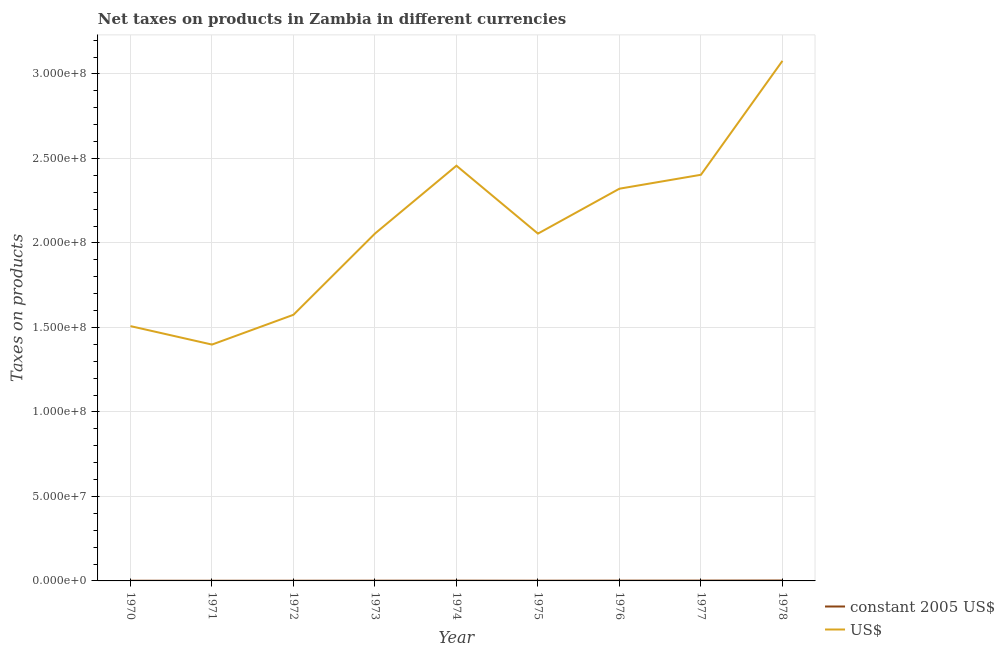Is the number of lines equal to the number of legend labels?
Ensure brevity in your answer.  Yes. What is the net taxes in constant 2005 us$ in 1977?
Your answer should be compact. 1.90e+05. Across all years, what is the maximum net taxes in constant 2005 us$?
Provide a succinct answer. 2.46e+05. Across all years, what is the minimum net taxes in us$?
Offer a terse response. 1.40e+08. In which year was the net taxes in constant 2005 us$ maximum?
Your response must be concise. 1978. What is the total net taxes in us$ in the graph?
Your answer should be compact. 1.89e+09. What is the difference between the net taxes in constant 2005 us$ in 1973 and that in 1978?
Provide a short and direct response. -1.12e+05. What is the difference between the net taxes in constant 2005 us$ in 1977 and the net taxes in us$ in 1973?
Give a very brief answer. -2.05e+08. What is the average net taxes in us$ per year?
Provide a succinct answer. 2.09e+08. In the year 1977, what is the difference between the net taxes in us$ and net taxes in constant 2005 us$?
Offer a terse response. 2.40e+08. In how many years, is the net taxes in us$ greater than 100000000 units?
Keep it short and to the point. 9. What is the ratio of the net taxes in constant 2005 us$ in 1973 to that in 1974?
Ensure brevity in your answer.  0.85. Is the difference between the net taxes in constant 2005 us$ in 1972 and 1976 greater than the difference between the net taxes in us$ in 1972 and 1976?
Your response must be concise. Yes. What is the difference between the highest and the second highest net taxes in constant 2005 us$?
Keep it short and to the point. 5.66e+04. What is the difference between the highest and the lowest net taxes in us$?
Keep it short and to the point. 1.68e+08. Does the net taxes in us$ monotonically increase over the years?
Your response must be concise. No. Is the net taxes in us$ strictly greater than the net taxes in constant 2005 us$ over the years?
Give a very brief answer. Yes. Is the net taxes in us$ strictly less than the net taxes in constant 2005 us$ over the years?
Provide a short and direct response. No. How many lines are there?
Ensure brevity in your answer.  2. How many years are there in the graph?
Provide a succinct answer. 9. Does the graph contain any zero values?
Keep it short and to the point. No. Does the graph contain grids?
Your answer should be compact. Yes. How many legend labels are there?
Your response must be concise. 2. What is the title of the graph?
Make the answer very short. Net taxes on products in Zambia in different currencies. What is the label or title of the Y-axis?
Your response must be concise. Taxes on products. What is the Taxes on products of constant 2005 US$ in 1970?
Your answer should be very brief. 1.08e+05. What is the Taxes on products in US$ in 1970?
Offer a very short reply. 1.51e+08. What is the Taxes on products in constant 2005 US$ in 1971?
Ensure brevity in your answer.  9.99e+04. What is the Taxes on products in US$ in 1971?
Keep it short and to the point. 1.40e+08. What is the Taxes on products in constant 2005 US$ in 1972?
Provide a succinct answer. 1.12e+05. What is the Taxes on products in US$ in 1972?
Provide a succinct answer. 1.57e+08. What is the Taxes on products in constant 2005 US$ in 1973?
Your answer should be compact. 1.34e+05. What is the Taxes on products in US$ in 1973?
Offer a very short reply. 2.06e+08. What is the Taxes on products of constant 2005 US$ in 1974?
Make the answer very short. 1.58e+05. What is the Taxes on products in US$ in 1974?
Your response must be concise. 2.46e+08. What is the Taxes on products in constant 2005 US$ in 1975?
Your answer should be compact. 1.32e+05. What is the Taxes on products in US$ in 1975?
Give a very brief answer. 2.06e+08. What is the Taxes on products in constant 2005 US$ in 1976?
Make the answer very short. 1.63e+05. What is the Taxes on products in US$ in 1976?
Provide a succinct answer. 2.32e+08. What is the Taxes on products in constant 2005 US$ in 1977?
Your answer should be compact. 1.90e+05. What is the Taxes on products of US$ in 1977?
Keep it short and to the point. 2.40e+08. What is the Taxes on products in constant 2005 US$ in 1978?
Provide a short and direct response. 2.46e+05. What is the Taxes on products of US$ in 1978?
Provide a short and direct response. 3.08e+08. Across all years, what is the maximum Taxes on products of constant 2005 US$?
Offer a very short reply. 2.46e+05. Across all years, what is the maximum Taxes on products of US$?
Provide a short and direct response. 3.08e+08. Across all years, what is the minimum Taxes on products of constant 2005 US$?
Your answer should be very brief. 9.99e+04. Across all years, what is the minimum Taxes on products in US$?
Your response must be concise. 1.40e+08. What is the total Taxes on products of constant 2005 US$ in the graph?
Offer a very short reply. 1.34e+06. What is the total Taxes on products in US$ in the graph?
Your answer should be very brief. 1.89e+09. What is the difference between the Taxes on products in constant 2005 US$ in 1970 and that in 1971?
Make the answer very short. 7800. What is the difference between the Taxes on products of US$ in 1970 and that in 1971?
Keep it short and to the point. 1.09e+07. What is the difference between the Taxes on products in constant 2005 US$ in 1970 and that in 1972?
Keep it short and to the point. -4800. What is the difference between the Taxes on products of US$ in 1970 and that in 1972?
Ensure brevity in your answer.  -6.71e+06. What is the difference between the Taxes on products of constant 2005 US$ in 1970 and that in 1973?
Give a very brief answer. -2.64e+04. What is the difference between the Taxes on products in US$ in 1970 and that in 1973?
Keep it short and to the point. -5.48e+07. What is the difference between the Taxes on products in constant 2005 US$ in 1970 and that in 1974?
Offer a terse response. -5.04e+04. What is the difference between the Taxes on products in US$ in 1970 and that in 1974?
Ensure brevity in your answer.  -9.49e+07. What is the difference between the Taxes on products in constant 2005 US$ in 1970 and that in 1975?
Keep it short and to the point. -2.45e+04. What is the difference between the Taxes on products of US$ in 1970 and that in 1975?
Keep it short and to the point. -5.47e+07. What is the difference between the Taxes on products of constant 2005 US$ in 1970 and that in 1976?
Your answer should be compact. -5.50e+04. What is the difference between the Taxes on products in US$ in 1970 and that in 1976?
Your answer should be very brief. -8.13e+07. What is the difference between the Taxes on products of constant 2005 US$ in 1970 and that in 1977?
Provide a short and direct response. -8.21e+04. What is the difference between the Taxes on products in US$ in 1970 and that in 1977?
Your answer should be compact. -8.96e+07. What is the difference between the Taxes on products of constant 2005 US$ in 1970 and that in 1978?
Ensure brevity in your answer.  -1.39e+05. What is the difference between the Taxes on products in US$ in 1970 and that in 1978?
Offer a very short reply. -1.57e+08. What is the difference between the Taxes on products of constant 2005 US$ in 1971 and that in 1972?
Your answer should be compact. -1.26e+04. What is the difference between the Taxes on products of US$ in 1971 and that in 1972?
Provide a short and direct response. -1.76e+07. What is the difference between the Taxes on products of constant 2005 US$ in 1971 and that in 1973?
Offer a very short reply. -3.42e+04. What is the difference between the Taxes on products in US$ in 1971 and that in 1973?
Provide a succinct answer. -6.57e+07. What is the difference between the Taxes on products in constant 2005 US$ in 1971 and that in 1974?
Make the answer very short. -5.82e+04. What is the difference between the Taxes on products of US$ in 1971 and that in 1974?
Keep it short and to the point. -1.06e+08. What is the difference between the Taxes on products in constant 2005 US$ in 1971 and that in 1975?
Give a very brief answer. -3.23e+04. What is the difference between the Taxes on products of US$ in 1971 and that in 1975?
Offer a very short reply. -6.57e+07. What is the difference between the Taxes on products of constant 2005 US$ in 1971 and that in 1976?
Offer a very short reply. -6.28e+04. What is the difference between the Taxes on products of US$ in 1971 and that in 1976?
Provide a succinct answer. -9.22e+07. What is the difference between the Taxes on products of constant 2005 US$ in 1971 and that in 1977?
Provide a short and direct response. -8.99e+04. What is the difference between the Taxes on products of US$ in 1971 and that in 1977?
Your response must be concise. -1.00e+08. What is the difference between the Taxes on products of constant 2005 US$ in 1971 and that in 1978?
Offer a very short reply. -1.46e+05. What is the difference between the Taxes on products in US$ in 1971 and that in 1978?
Provide a succinct answer. -1.68e+08. What is the difference between the Taxes on products of constant 2005 US$ in 1972 and that in 1973?
Your answer should be very brief. -2.16e+04. What is the difference between the Taxes on products in US$ in 1972 and that in 1973?
Offer a terse response. -4.81e+07. What is the difference between the Taxes on products of constant 2005 US$ in 1972 and that in 1974?
Offer a very short reply. -4.56e+04. What is the difference between the Taxes on products of US$ in 1972 and that in 1974?
Ensure brevity in your answer.  -8.82e+07. What is the difference between the Taxes on products in constant 2005 US$ in 1972 and that in 1975?
Your answer should be compact. -1.97e+04. What is the difference between the Taxes on products in US$ in 1972 and that in 1975?
Make the answer very short. -4.80e+07. What is the difference between the Taxes on products in constant 2005 US$ in 1972 and that in 1976?
Make the answer very short. -5.02e+04. What is the difference between the Taxes on products of US$ in 1972 and that in 1976?
Offer a terse response. -7.46e+07. What is the difference between the Taxes on products in constant 2005 US$ in 1972 and that in 1977?
Keep it short and to the point. -7.73e+04. What is the difference between the Taxes on products in US$ in 1972 and that in 1977?
Provide a short and direct response. -8.28e+07. What is the difference between the Taxes on products in constant 2005 US$ in 1972 and that in 1978?
Offer a terse response. -1.34e+05. What is the difference between the Taxes on products in US$ in 1972 and that in 1978?
Give a very brief answer. -1.50e+08. What is the difference between the Taxes on products of constant 2005 US$ in 1973 and that in 1974?
Your answer should be very brief. -2.40e+04. What is the difference between the Taxes on products of US$ in 1973 and that in 1974?
Ensure brevity in your answer.  -4.02e+07. What is the difference between the Taxes on products of constant 2005 US$ in 1973 and that in 1975?
Provide a short and direct response. 1900. What is the difference between the Taxes on products of US$ in 1973 and that in 1975?
Give a very brief answer. 2.46e+04. What is the difference between the Taxes on products of constant 2005 US$ in 1973 and that in 1976?
Provide a short and direct response. -2.86e+04. What is the difference between the Taxes on products in US$ in 1973 and that in 1976?
Make the answer very short. -2.66e+07. What is the difference between the Taxes on products in constant 2005 US$ in 1973 and that in 1977?
Make the answer very short. -5.57e+04. What is the difference between the Taxes on products in US$ in 1973 and that in 1977?
Keep it short and to the point. -3.48e+07. What is the difference between the Taxes on products of constant 2005 US$ in 1973 and that in 1978?
Provide a short and direct response. -1.12e+05. What is the difference between the Taxes on products in US$ in 1973 and that in 1978?
Ensure brevity in your answer.  -1.02e+08. What is the difference between the Taxes on products of constant 2005 US$ in 1974 and that in 1975?
Ensure brevity in your answer.  2.59e+04. What is the difference between the Taxes on products of US$ in 1974 and that in 1975?
Your response must be concise. 4.02e+07. What is the difference between the Taxes on products of constant 2005 US$ in 1974 and that in 1976?
Your answer should be very brief. -4600. What is the difference between the Taxes on products in US$ in 1974 and that in 1976?
Offer a very short reply. 1.36e+07. What is the difference between the Taxes on products of constant 2005 US$ in 1974 and that in 1977?
Offer a very short reply. -3.17e+04. What is the difference between the Taxes on products in US$ in 1974 and that in 1977?
Give a very brief answer. 5.37e+06. What is the difference between the Taxes on products of constant 2005 US$ in 1974 and that in 1978?
Provide a short and direct response. -8.83e+04. What is the difference between the Taxes on products in US$ in 1974 and that in 1978?
Your answer should be very brief. -6.20e+07. What is the difference between the Taxes on products of constant 2005 US$ in 1975 and that in 1976?
Ensure brevity in your answer.  -3.05e+04. What is the difference between the Taxes on products in US$ in 1975 and that in 1976?
Provide a short and direct response. -2.66e+07. What is the difference between the Taxes on products of constant 2005 US$ in 1975 and that in 1977?
Provide a short and direct response. -5.76e+04. What is the difference between the Taxes on products in US$ in 1975 and that in 1977?
Offer a very short reply. -3.48e+07. What is the difference between the Taxes on products of constant 2005 US$ in 1975 and that in 1978?
Give a very brief answer. -1.14e+05. What is the difference between the Taxes on products in US$ in 1975 and that in 1978?
Make the answer very short. -1.02e+08. What is the difference between the Taxes on products in constant 2005 US$ in 1976 and that in 1977?
Offer a very short reply. -2.71e+04. What is the difference between the Taxes on products of US$ in 1976 and that in 1977?
Your answer should be compact. -8.23e+06. What is the difference between the Taxes on products of constant 2005 US$ in 1976 and that in 1978?
Ensure brevity in your answer.  -8.37e+04. What is the difference between the Taxes on products in US$ in 1976 and that in 1978?
Your response must be concise. -7.56e+07. What is the difference between the Taxes on products in constant 2005 US$ in 1977 and that in 1978?
Provide a short and direct response. -5.66e+04. What is the difference between the Taxes on products in US$ in 1977 and that in 1978?
Offer a very short reply. -6.74e+07. What is the difference between the Taxes on products in constant 2005 US$ in 1970 and the Taxes on products in US$ in 1971?
Your response must be concise. -1.40e+08. What is the difference between the Taxes on products of constant 2005 US$ in 1970 and the Taxes on products of US$ in 1972?
Keep it short and to the point. -1.57e+08. What is the difference between the Taxes on products in constant 2005 US$ in 1970 and the Taxes on products in US$ in 1973?
Your response must be concise. -2.05e+08. What is the difference between the Taxes on products of constant 2005 US$ in 1970 and the Taxes on products of US$ in 1974?
Your answer should be compact. -2.46e+08. What is the difference between the Taxes on products in constant 2005 US$ in 1970 and the Taxes on products in US$ in 1975?
Ensure brevity in your answer.  -2.05e+08. What is the difference between the Taxes on products in constant 2005 US$ in 1970 and the Taxes on products in US$ in 1976?
Keep it short and to the point. -2.32e+08. What is the difference between the Taxes on products in constant 2005 US$ in 1970 and the Taxes on products in US$ in 1977?
Offer a very short reply. -2.40e+08. What is the difference between the Taxes on products of constant 2005 US$ in 1970 and the Taxes on products of US$ in 1978?
Keep it short and to the point. -3.08e+08. What is the difference between the Taxes on products of constant 2005 US$ in 1971 and the Taxes on products of US$ in 1972?
Keep it short and to the point. -1.57e+08. What is the difference between the Taxes on products in constant 2005 US$ in 1971 and the Taxes on products in US$ in 1973?
Your answer should be very brief. -2.05e+08. What is the difference between the Taxes on products in constant 2005 US$ in 1971 and the Taxes on products in US$ in 1974?
Give a very brief answer. -2.46e+08. What is the difference between the Taxes on products in constant 2005 US$ in 1971 and the Taxes on products in US$ in 1975?
Make the answer very short. -2.05e+08. What is the difference between the Taxes on products of constant 2005 US$ in 1971 and the Taxes on products of US$ in 1976?
Provide a succinct answer. -2.32e+08. What is the difference between the Taxes on products in constant 2005 US$ in 1971 and the Taxes on products in US$ in 1977?
Offer a terse response. -2.40e+08. What is the difference between the Taxes on products of constant 2005 US$ in 1971 and the Taxes on products of US$ in 1978?
Make the answer very short. -3.08e+08. What is the difference between the Taxes on products in constant 2005 US$ in 1972 and the Taxes on products in US$ in 1973?
Your response must be concise. -2.05e+08. What is the difference between the Taxes on products in constant 2005 US$ in 1972 and the Taxes on products in US$ in 1974?
Offer a terse response. -2.46e+08. What is the difference between the Taxes on products of constant 2005 US$ in 1972 and the Taxes on products of US$ in 1975?
Your answer should be very brief. -2.05e+08. What is the difference between the Taxes on products in constant 2005 US$ in 1972 and the Taxes on products in US$ in 1976?
Ensure brevity in your answer.  -2.32e+08. What is the difference between the Taxes on products of constant 2005 US$ in 1972 and the Taxes on products of US$ in 1977?
Give a very brief answer. -2.40e+08. What is the difference between the Taxes on products in constant 2005 US$ in 1972 and the Taxes on products in US$ in 1978?
Ensure brevity in your answer.  -3.08e+08. What is the difference between the Taxes on products of constant 2005 US$ in 1973 and the Taxes on products of US$ in 1974?
Keep it short and to the point. -2.46e+08. What is the difference between the Taxes on products of constant 2005 US$ in 1973 and the Taxes on products of US$ in 1975?
Make the answer very short. -2.05e+08. What is the difference between the Taxes on products in constant 2005 US$ in 1973 and the Taxes on products in US$ in 1976?
Offer a very short reply. -2.32e+08. What is the difference between the Taxes on products of constant 2005 US$ in 1973 and the Taxes on products of US$ in 1977?
Offer a terse response. -2.40e+08. What is the difference between the Taxes on products in constant 2005 US$ in 1973 and the Taxes on products in US$ in 1978?
Provide a short and direct response. -3.08e+08. What is the difference between the Taxes on products in constant 2005 US$ in 1974 and the Taxes on products in US$ in 1975?
Your answer should be compact. -2.05e+08. What is the difference between the Taxes on products in constant 2005 US$ in 1974 and the Taxes on products in US$ in 1976?
Offer a terse response. -2.32e+08. What is the difference between the Taxes on products in constant 2005 US$ in 1974 and the Taxes on products in US$ in 1977?
Make the answer very short. -2.40e+08. What is the difference between the Taxes on products of constant 2005 US$ in 1974 and the Taxes on products of US$ in 1978?
Provide a short and direct response. -3.08e+08. What is the difference between the Taxes on products in constant 2005 US$ in 1975 and the Taxes on products in US$ in 1976?
Offer a terse response. -2.32e+08. What is the difference between the Taxes on products of constant 2005 US$ in 1975 and the Taxes on products of US$ in 1977?
Offer a terse response. -2.40e+08. What is the difference between the Taxes on products of constant 2005 US$ in 1975 and the Taxes on products of US$ in 1978?
Make the answer very short. -3.08e+08. What is the difference between the Taxes on products in constant 2005 US$ in 1976 and the Taxes on products in US$ in 1977?
Your answer should be very brief. -2.40e+08. What is the difference between the Taxes on products in constant 2005 US$ in 1976 and the Taxes on products in US$ in 1978?
Provide a short and direct response. -3.08e+08. What is the difference between the Taxes on products in constant 2005 US$ in 1977 and the Taxes on products in US$ in 1978?
Give a very brief answer. -3.08e+08. What is the average Taxes on products of constant 2005 US$ per year?
Your answer should be very brief. 1.49e+05. What is the average Taxes on products in US$ per year?
Keep it short and to the point. 2.09e+08. In the year 1970, what is the difference between the Taxes on products in constant 2005 US$ and Taxes on products in US$?
Your answer should be very brief. -1.51e+08. In the year 1971, what is the difference between the Taxes on products of constant 2005 US$ and Taxes on products of US$?
Make the answer very short. -1.40e+08. In the year 1972, what is the difference between the Taxes on products of constant 2005 US$ and Taxes on products of US$?
Keep it short and to the point. -1.57e+08. In the year 1973, what is the difference between the Taxes on products in constant 2005 US$ and Taxes on products in US$?
Give a very brief answer. -2.05e+08. In the year 1974, what is the difference between the Taxes on products in constant 2005 US$ and Taxes on products in US$?
Ensure brevity in your answer.  -2.46e+08. In the year 1975, what is the difference between the Taxes on products of constant 2005 US$ and Taxes on products of US$?
Your response must be concise. -2.05e+08. In the year 1976, what is the difference between the Taxes on products of constant 2005 US$ and Taxes on products of US$?
Give a very brief answer. -2.32e+08. In the year 1977, what is the difference between the Taxes on products of constant 2005 US$ and Taxes on products of US$?
Your response must be concise. -2.40e+08. In the year 1978, what is the difference between the Taxes on products in constant 2005 US$ and Taxes on products in US$?
Ensure brevity in your answer.  -3.07e+08. What is the ratio of the Taxes on products of constant 2005 US$ in 1970 to that in 1971?
Make the answer very short. 1.08. What is the ratio of the Taxes on products of US$ in 1970 to that in 1971?
Your response must be concise. 1.08. What is the ratio of the Taxes on products of constant 2005 US$ in 1970 to that in 1972?
Provide a succinct answer. 0.96. What is the ratio of the Taxes on products of US$ in 1970 to that in 1972?
Give a very brief answer. 0.96. What is the ratio of the Taxes on products of constant 2005 US$ in 1970 to that in 1973?
Your response must be concise. 0.8. What is the ratio of the Taxes on products in US$ in 1970 to that in 1973?
Give a very brief answer. 0.73. What is the ratio of the Taxes on products in constant 2005 US$ in 1970 to that in 1974?
Provide a short and direct response. 0.68. What is the ratio of the Taxes on products of US$ in 1970 to that in 1974?
Provide a short and direct response. 0.61. What is the ratio of the Taxes on products in constant 2005 US$ in 1970 to that in 1975?
Provide a succinct answer. 0.81. What is the ratio of the Taxes on products in US$ in 1970 to that in 1975?
Offer a very short reply. 0.73. What is the ratio of the Taxes on products of constant 2005 US$ in 1970 to that in 1976?
Provide a short and direct response. 0.66. What is the ratio of the Taxes on products of US$ in 1970 to that in 1976?
Provide a short and direct response. 0.65. What is the ratio of the Taxes on products of constant 2005 US$ in 1970 to that in 1977?
Provide a succinct answer. 0.57. What is the ratio of the Taxes on products in US$ in 1970 to that in 1977?
Ensure brevity in your answer.  0.63. What is the ratio of the Taxes on products in constant 2005 US$ in 1970 to that in 1978?
Your answer should be very brief. 0.44. What is the ratio of the Taxes on products of US$ in 1970 to that in 1978?
Make the answer very short. 0.49. What is the ratio of the Taxes on products of constant 2005 US$ in 1971 to that in 1972?
Provide a short and direct response. 0.89. What is the ratio of the Taxes on products of US$ in 1971 to that in 1972?
Offer a very short reply. 0.89. What is the ratio of the Taxes on products in constant 2005 US$ in 1971 to that in 1973?
Your answer should be very brief. 0.74. What is the ratio of the Taxes on products in US$ in 1971 to that in 1973?
Your answer should be very brief. 0.68. What is the ratio of the Taxes on products in constant 2005 US$ in 1971 to that in 1974?
Keep it short and to the point. 0.63. What is the ratio of the Taxes on products of US$ in 1971 to that in 1974?
Provide a short and direct response. 0.57. What is the ratio of the Taxes on products in constant 2005 US$ in 1971 to that in 1975?
Your answer should be very brief. 0.76. What is the ratio of the Taxes on products of US$ in 1971 to that in 1975?
Offer a very short reply. 0.68. What is the ratio of the Taxes on products of constant 2005 US$ in 1971 to that in 1976?
Keep it short and to the point. 0.61. What is the ratio of the Taxes on products in US$ in 1971 to that in 1976?
Offer a terse response. 0.6. What is the ratio of the Taxes on products in constant 2005 US$ in 1971 to that in 1977?
Make the answer very short. 0.53. What is the ratio of the Taxes on products of US$ in 1971 to that in 1977?
Offer a very short reply. 0.58. What is the ratio of the Taxes on products in constant 2005 US$ in 1971 to that in 1978?
Your response must be concise. 0.41. What is the ratio of the Taxes on products in US$ in 1971 to that in 1978?
Provide a succinct answer. 0.45. What is the ratio of the Taxes on products in constant 2005 US$ in 1972 to that in 1973?
Your response must be concise. 0.84. What is the ratio of the Taxes on products of US$ in 1972 to that in 1973?
Your answer should be compact. 0.77. What is the ratio of the Taxes on products in constant 2005 US$ in 1972 to that in 1974?
Provide a succinct answer. 0.71. What is the ratio of the Taxes on products of US$ in 1972 to that in 1974?
Ensure brevity in your answer.  0.64. What is the ratio of the Taxes on products in constant 2005 US$ in 1972 to that in 1975?
Keep it short and to the point. 0.85. What is the ratio of the Taxes on products in US$ in 1972 to that in 1975?
Your answer should be compact. 0.77. What is the ratio of the Taxes on products of constant 2005 US$ in 1972 to that in 1976?
Give a very brief answer. 0.69. What is the ratio of the Taxes on products of US$ in 1972 to that in 1976?
Provide a succinct answer. 0.68. What is the ratio of the Taxes on products of constant 2005 US$ in 1972 to that in 1977?
Keep it short and to the point. 0.59. What is the ratio of the Taxes on products in US$ in 1972 to that in 1977?
Your answer should be compact. 0.66. What is the ratio of the Taxes on products in constant 2005 US$ in 1972 to that in 1978?
Make the answer very short. 0.46. What is the ratio of the Taxes on products in US$ in 1972 to that in 1978?
Provide a short and direct response. 0.51. What is the ratio of the Taxes on products in constant 2005 US$ in 1973 to that in 1974?
Ensure brevity in your answer.  0.85. What is the ratio of the Taxes on products in US$ in 1973 to that in 1974?
Ensure brevity in your answer.  0.84. What is the ratio of the Taxes on products of constant 2005 US$ in 1973 to that in 1975?
Keep it short and to the point. 1.01. What is the ratio of the Taxes on products of constant 2005 US$ in 1973 to that in 1976?
Provide a short and direct response. 0.82. What is the ratio of the Taxes on products of US$ in 1973 to that in 1976?
Offer a terse response. 0.89. What is the ratio of the Taxes on products of constant 2005 US$ in 1973 to that in 1977?
Offer a terse response. 0.71. What is the ratio of the Taxes on products of US$ in 1973 to that in 1977?
Your answer should be very brief. 0.86. What is the ratio of the Taxes on products of constant 2005 US$ in 1973 to that in 1978?
Provide a succinct answer. 0.54. What is the ratio of the Taxes on products of US$ in 1973 to that in 1978?
Your answer should be compact. 0.67. What is the ratio of the Taxes on products in constant 2005 US$ in 1974 to that in 1975?
Offer a very short reply. 1.2. What is the ratio of the Taxes on products in US$ in 1974 to that in 1975?
Provide a succinct answer. 1.2. What is the ratio of the Taxes on products in constant 2005 US$ in 1974 to that in 1976?
Your response must be concise. 0.97. What is the ratio of the Taxes on products in US$ in 1974 to that in 1976?
Your answer should be compact. 1.06. What is the ratio of the Taxes on products in constant 2005 US$ in 1974 to that in 1977?
Ensure brevity in your answer.  0.83. What is the ratio of the Taxes on products in US$ in 1974 to that in 1977?
Offer a terse response. 1.02. What is the ratio of the Taxes on products in constant 2005 US$ in 1974 to that in 1978?
Provide a short and direct response. 0.64. What is the ratio of the Taxes on products in US$ in 1974 to that in 1978?
Keep it short and to the point. 0.8. What is the ratio of the Taxes on products of constant 2005 US$ in 1975 to that in 1976?
Your answer should be very brief. 0.81. What is the ratio of the Taxes on products in US$ in 1975 to that in 1976?
Keep it short and to the point. 0.89. What is the ratio of the Taxes on products in constant 2005 US$ in 1975 to that in 1977?
Make the answer very short. 0.7. What is the ratio of the Taxes on products in US$ in 1975 to that in 1977?
Give a very brief answer. 0.86. What is the ratio of the Taxes on products of constant 2005 US$ in 1975 to that in 1978?
Offer a terse response. 0.54. What is the ratio of the Taxes on products in US$ in 1975 to that in 1978?
Offer a terse response. 0.67. What is the ratio of the Taxes on products of constant 2005 US$ in 1976 to that in 1977?
Make the answer very short. 0.86. What is the ratio of the Taxes on products of US$ in 1976 to that in 1977?
Provide a succinct answer. 0.97. What is the ratio of the Taxes on products of constant 2005 US$ in 1976 to that in 1978?
Give a very brief answer. 0.66. What is the ratio of the Taxes on products in US$ in 1976 to that in 1978?
Your response must be concise. 0.75. What is the ratio of the Taxes on products in constant 2005 US$ in 1977 to that in 1978?
Give a very brief answer. 0.77. What is the ratio of the Taxes on products in US$ in 1977 to that in 1978?
Give a very brief answer. 0.78. What is the difference between the highest and the second highest Taxes on products of constant 2005 US$?
Keep it short and to the point. 5.66e+04. What is the difference between the highest and the second highest Taxes on products of US$?
Your answer should be very brief. 6.20e+07. What is the difference between the highest and the lowest Taxes on products in constant 2005 US$?
Provide a short and direct response. 1.46e+05. What is the difference between the highest and the lowest Taxes on products in US$?
Your answer should be very brief. 1.68e+08. 